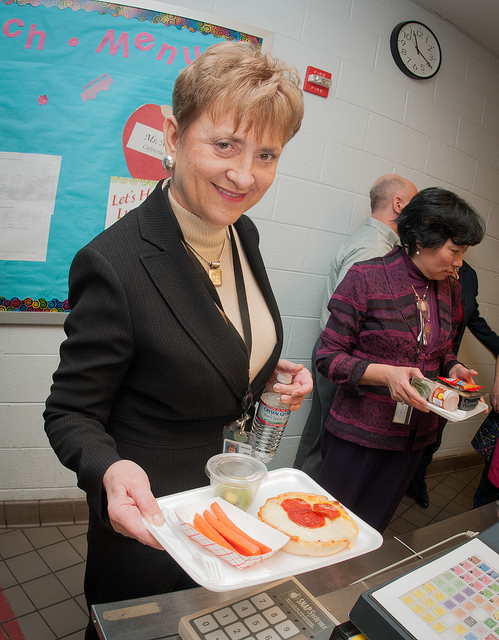How would you explain the importance of such meals in an educational environment? Balanced meals, such as those being served here, are crucial in educational environments because they provide students with the necessary nutrients to sustain energy levels, focus better in class, and overall maintain good health and growth. Are such meals common in education institutions? Yes, many educational institutions strive to offer balanced meals, adhering to nutritional guidelines to promote healthy eating habits among students. Such meals help ensure all students have access to nutritious food during school hours. 